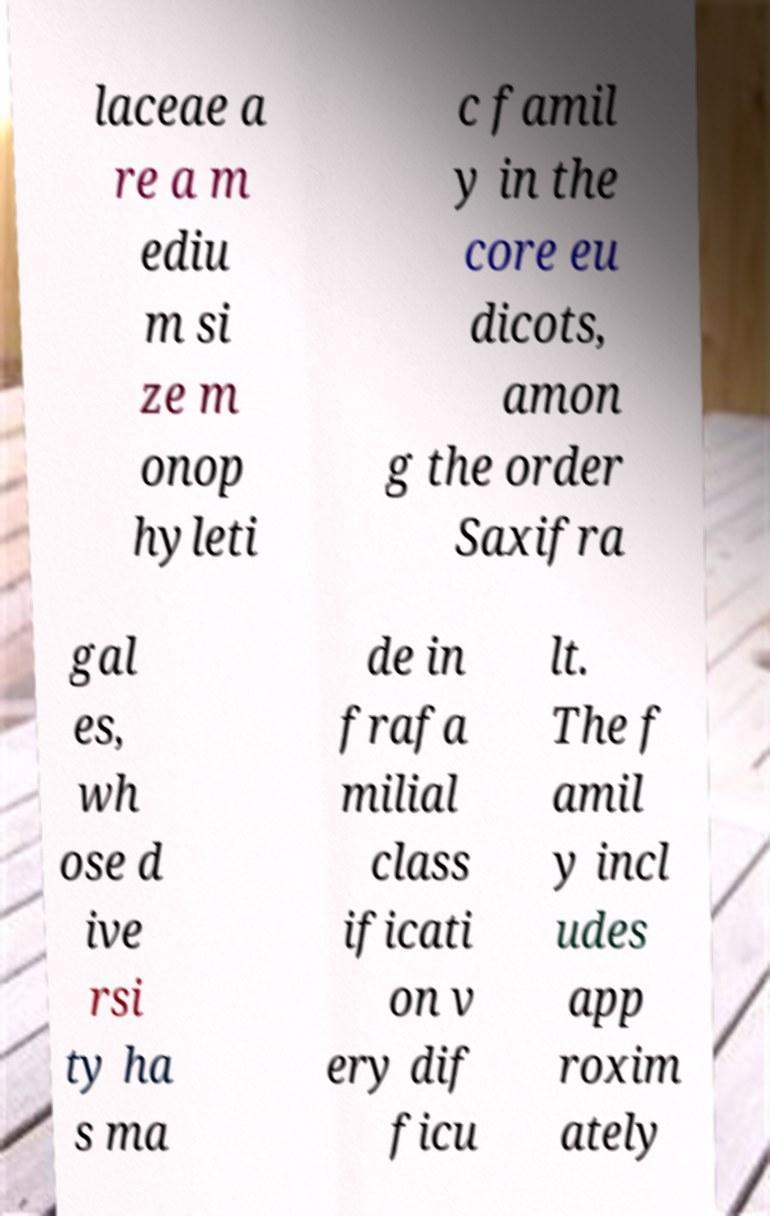Can you accurately transcribe the text from the provided image for me? laceae a re a m ediu m si ze m onop hyleti c famil y in the core eu dicots, amon g the order Saxifra gal es, wh ose d ive rsi ty ha s ma de in frafa milial class ificati on v ery dif ficu lt. The f amil y incl udes app roxim ately 